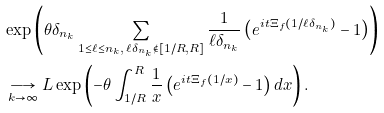<formula> <loc_0><loc_0><loc_500><loc_500>& \exp \left ( \theta \delta _ { n _ { k } } \sum _ { 1 \leq \ell \leq n _ { k } , \, \ell \delta _ { n _ { k } } \notin [ 1 / R , R ] } \frac { 1 } { \ell \delta _ { n _ { k } } } \left ( e ^ { i t \Xi _ { f } ( 1 / \ell \delta _ { n _ { k } } ) } - 1 \right ) \right ) \\ & \underset { k \rightarrow \infty } { \longrightarrow } L \exp \left ( - \theta \int _ { 1 / R } ^ { R } \frac { 1 } { x } \left ( e ^ { i t \Xi _ { f } ( 1 / x ) } - 1 \right ) d x \right ) .</formula> 